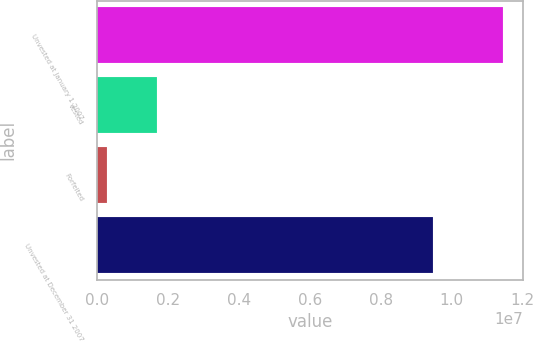Convert chart. <chart><loc_0><loc_0><loc_500><loc_500><bar_chart><fcel>Unvested at January 1 2007<fcel>Vested<fcel>Forfeited<fcel>Unvested at December 31 2007<nl><fcel>1.14438e+07<fcel>1.69131e+06<fcel>282657<fcel>9.46981e+06<nl></chart> 